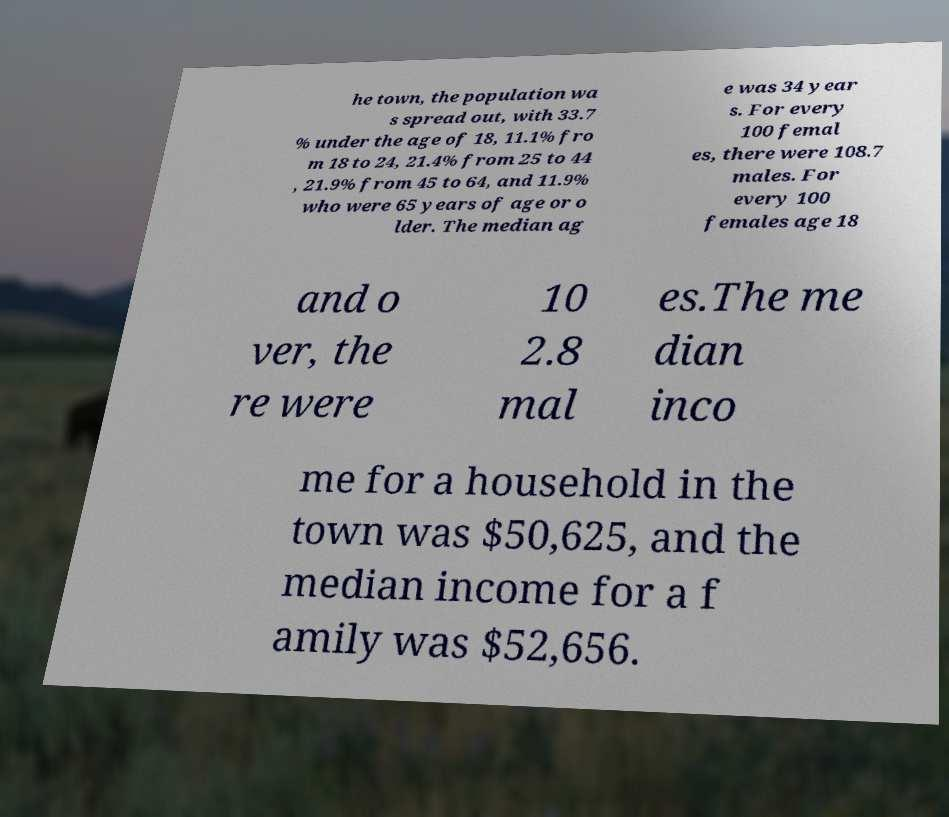Please identify and transcribe the text found in this image. he town, the population wa s spread out, with 33.7 % under the age of 18, 11.1% fro m 18 to 24, 21.4% from 25 to 44 , 21.9% from 45 to 64, and 11.9% who were 65 years of age or o lder. The median ag e was 34 year s. For every 100 femal es, there were 108.7 males. For every 100 females age 18 and o ver, the re were 10 2.8 mal es.The me dian inco me for a household in the town was $50,625, and the median income for a f amily was $52,656. 